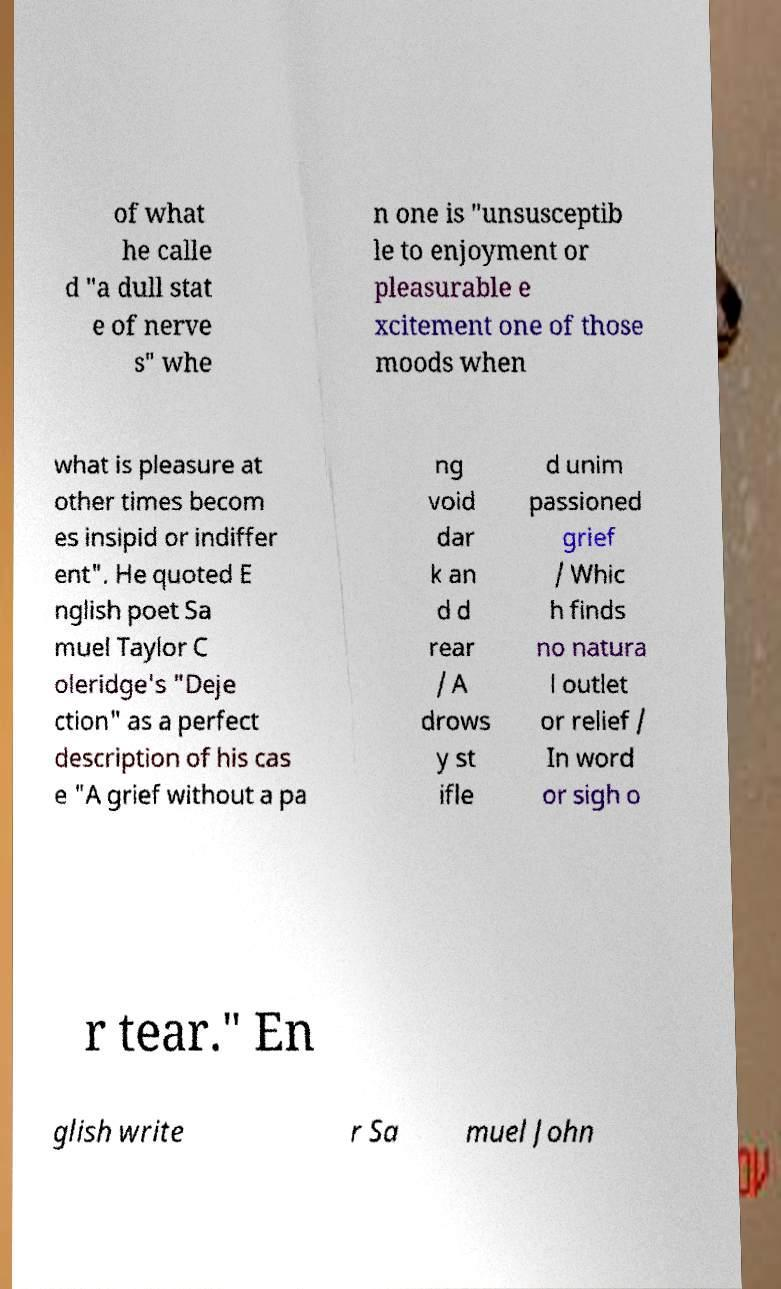I need the written content from this picture converted into text. Can you do that? of what he calle d "a dull stat e of nerve s" whe n one is "unsusceptib le to enjoyment or pleasurable e xcitement one of those moods when what is pleasure at other times becom es insipid or indiffer ent". He quoted E nglish poet Sa muel Taylor C oleridge's "Deje ction" as a perfect description of his cas e "A grief without a pa ng void dar k an d d rear / A drows y st ifle d unim passioned grief / Whic h finds no natura l outlet or relief / In word or sigh o r tear." En glish write r Sa muel John 